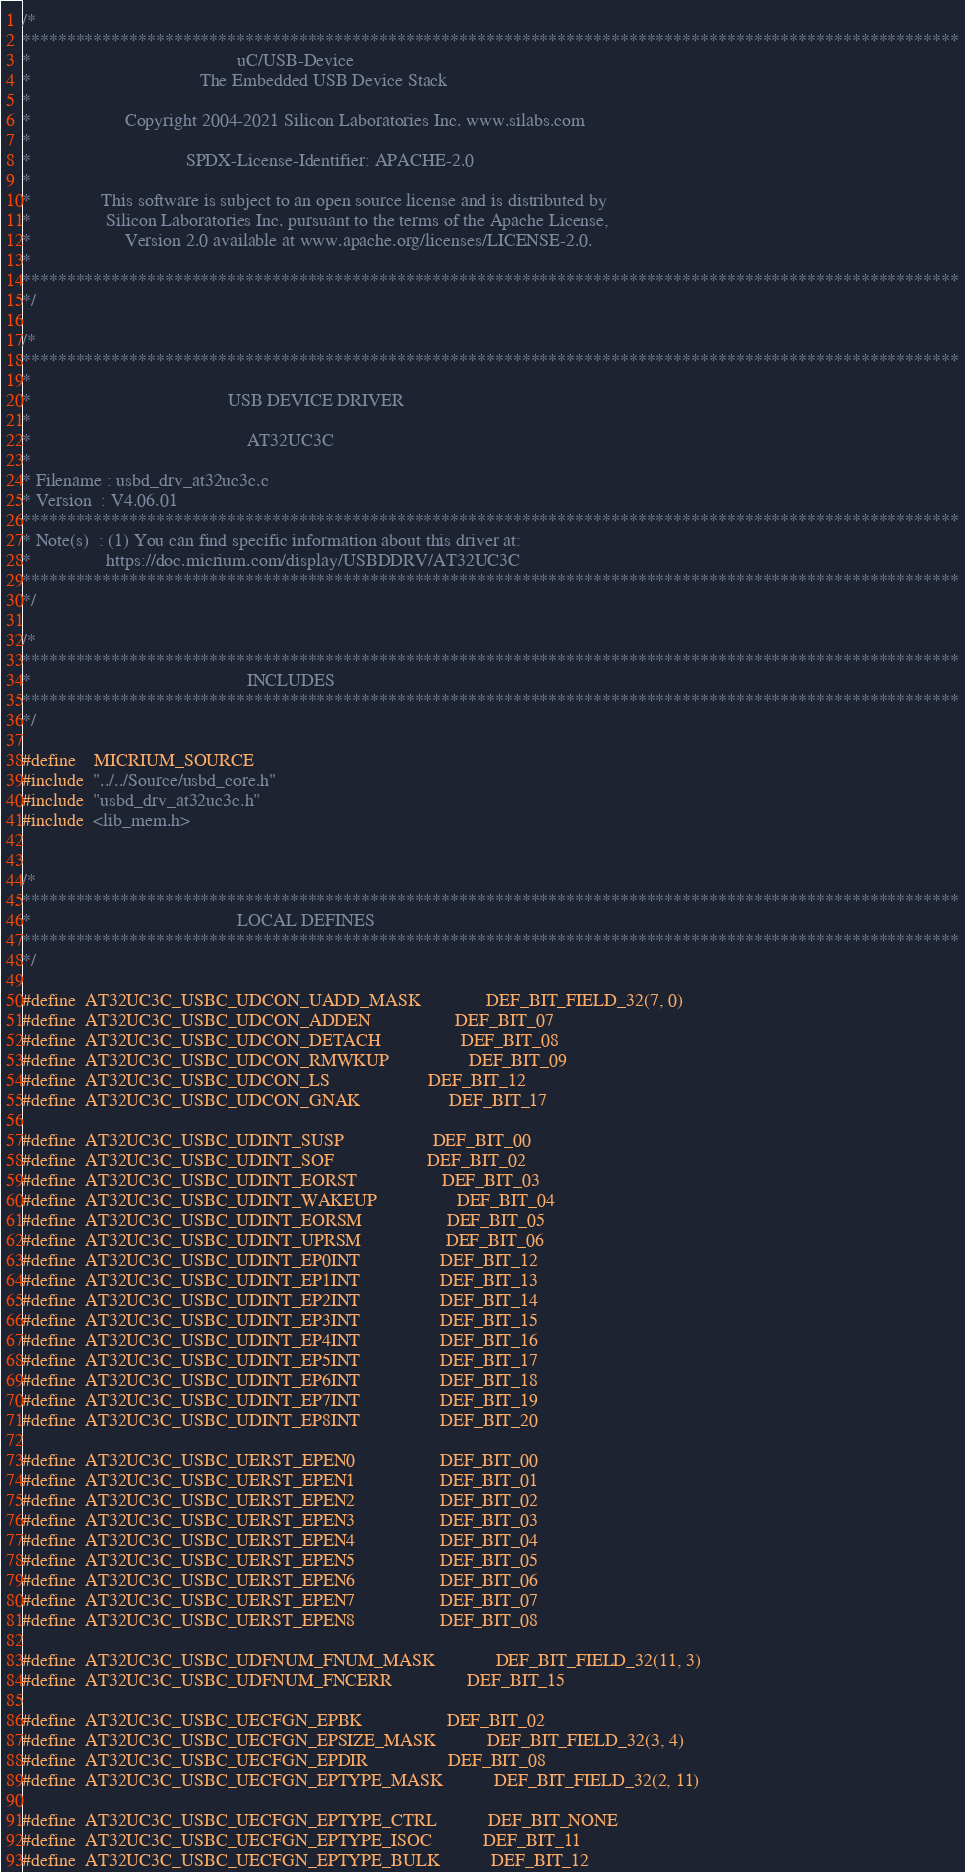<code> <loc_0><loc_0><loc_500><loc_500><_C_>/*
*********************************************************************************************************
*                                            uC/USB-Device
*                                    The Embedded USB Device Stack
*
*                    Copyright 2004-2021 Silicon Laboratories Inc. www.silabs.com
*
*                                 SPDX-License-Identifier: APACHE-2.0
*
*               This software is subject to an open source license and is distributed by
*                Silicon Laboratories Inc. pursuant to the terms of the Apache License,
*                    Version 2.0 available at www.apache.org/licenses/LICENSE-2.0.
*
*********************************************************************************************************
*/

/*
*********************************************************************************************************
*
*                                          USB DEVICE DRIVER
*
*                                              AT32UC3C
*
* Filename : usbd_drv_at32uc3c.c
* Version  : V4.06.01
*********************************************************************************************************
* Note(s)  : (1) You can find specific information about this driver at:
*                https://doc.micrium.com/display/USBDDRV/AT32UC3C
*********************************************************************************************************
*/

/*
*********************************************************************************************************
*                                              INCLUDES
*********************************************************************************************************
*/

#define    MICRIUM_SOURCE
#include  "../../Source/usbd_core.h"
#include  "usbd_drv_at32uc3c.h"
#include  <lib_mem.h>


/*
*********************************************************************************************************
*                                            LOCAL DEFINES
*********************************************************************************************************
*/

#define  AT32UC3C_USBC_UDCON_UADD_MASK              DEF_BIT_FIELD_32(7, 0)
#define  AT32UC3C_USBC_UDCON_ADDEN                  DEF_BIT_07
#define  AT32UC3C_USBC_UDCON_DETACH                 DEF_BIT_08
#define  AT32UC3C_USBC_UDCON_RMWKUP                 DEF_BIT_09
#define  AT32UC3C_USBC_UDCON_LS                     DEF_BIT_12
#define  AT32UC3C_USBC_UDCON_GNAK                   DEF_BIT_17

#define  AT32UC3C_USBC_UDINT_SUSP                   DEF_BIT_00
#define  AT32UC3C_USBC_UDINT_SOF                    DEF_BIT_02
#define  AT32UC3C_USBC_UDINT_EORST                  DEF_BIT_03
#define  AT32UC3C_USBC_UDINT_WAKEUP                 DEF_BIT_04
#define  AT32UC3C_USBC_UDINT_EORSM                  DEF_BIT_05
#define  AT32UC3C_USBC_UDINT_UPRSM                  DEF_BIT_06
#define  AT32UC3C_USBC_UDINT_EP0INT                 DEF_BIT_12
#define  AT32UC3C_USBC_UDINT_EP1INT                 DEF_BIT_13
#define  AT32UC3C_USBC_UDINT_EP2INT                 DEF_BIT_14
#define  AT32UC3C_USBC_UDINT_EP3INT                 DEF_BIT_15
#define  AT32UC3C_USBC_UDINT_EP4INT                 DEF_BIT_16
#define  AT32UC3C_USBC_UDINT_EP5INT                 DEF_BIT_17
#define  AT32UC3C_USBC_UDINT_EP6INT                 DEF_BIT_18
#define  AT32UC3C_USBC_UDINT_EP7INT                 DEF_BIT_19
#define  AT32UC3C_USBC_UDINT_EP8INT                 DEF_BIT_20

#define  AT32UC3C_USBC_UERST_EPEN0                  DEF_BIT_00
#define  AT32UC3C_USBC_UERST_EPEN1                  DEF_BIT_01
#define  AT32UC3C_USBC_UERST_EPEN2                  DEF_BIT_02
#define  AT32UC3C_USBC_UERST_EPEN3                  DEF_BIT_03
#define  AT32UC3C_USBC_UERST_EPEN4                  DEF_BIT_04
#define  AT32UC3C_USBC_UERST_EPEN5                  DEF_BIT_05
#define  AT32UC3C_USBC_UERST_EPEN6                  DEF_BIT_06
#define  AT32UC3C_USBC_UERST_EPEN7                  DEF_BIT_07
#define  AT32UC3C_USBC_UERST_EPEN8                  DEF_BIT_08

#define  AT32UC3C_USBC_UDFNUM_FNUM_MASK             DEF_BIT_FIELD_32(11, 3)
#define  AT32UC3C_USBC_UDFNUM_FNCERR                DEF_BIT_15

#define  AT32UC3C_USBC_UECFGN_EPBK                  DEF_BIT_02
#define  AT32UC3C_USBC_UECFGN_EPSIZE_MASK           DEF_BIT_FIELD_32(3, 4)
#define  AT32UC3C_USBC_UECFGN_EPDIR                 DEF_BIT_08
#define  AT32UC3C_USBC_UECFGN_EPTYPE_MASK           DEF_BIT_FIELD_32(2, 11)

#define  AT32UC3C_USBC_UECFGN_EPTYPE_CTRL           DEF_BIT_NONE
#define  AT32UC3C_USBC_UECFGN_EPTYPE_ISOC           DEF_BIT_11
#define  AT32UC3C_USBC_UECFGN_EPTYPE_BULK           DEF_BIT_12</code> 